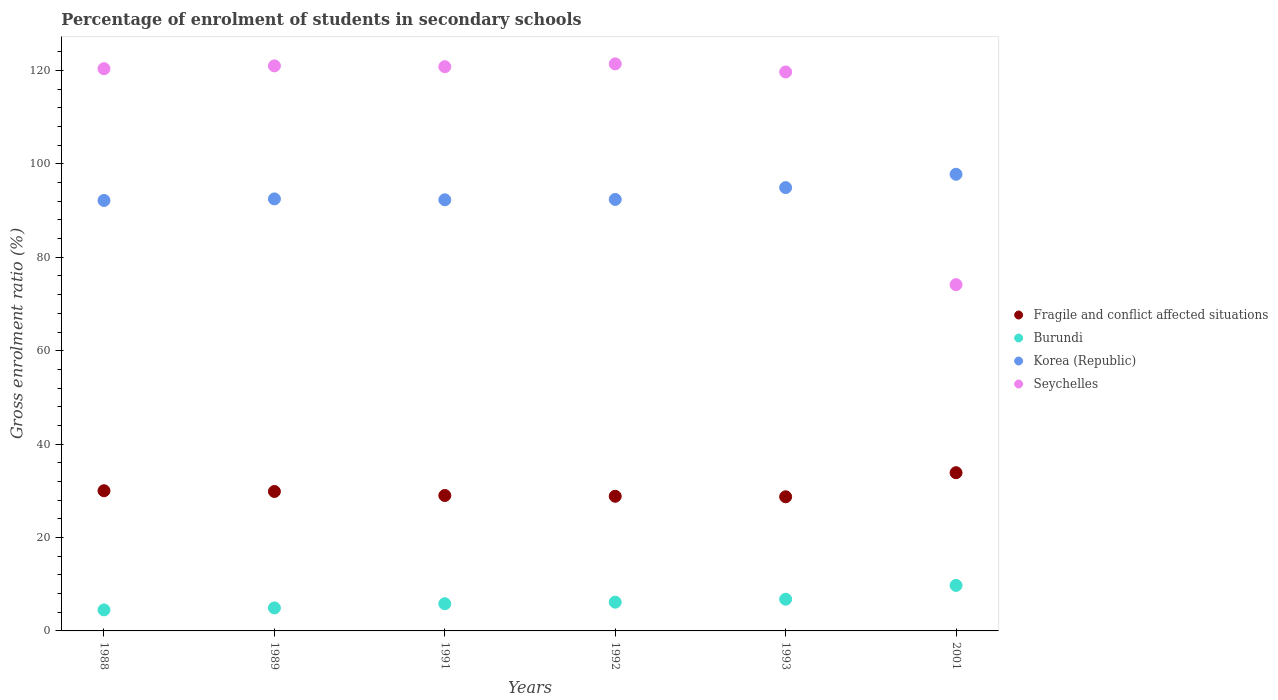How many different coloured dotlines are there?
Ensure brevity in your answer.  4. What is the percentage of students enrolled in secondary schools in Korea (Republic) in 2001?
Provide a short and direct response. 97.77. Across all years, what is the maximum percentage of students enrolled in secondary schools in Burundi?
Your answer should be very brief. 9.75. Across all years, what is the minimum percentage of students enrolled in secondary schools in Seychelles?
Provide a short and direct response. 74.14. In which year was the percentage of students enrolled in secondary schools in Fragile and conflict affected situations maximum?
Make the answer very short. 2001. In which year was the percentage of students enrolled in secondary schools in Fragile and conflict affected situations minimum?
Make the answer very short. 1993. What is the total percentage of students enrolled in secondary schools in Seychelles in the graph?
Ensure brevity in your answer.  677.37. What is the difference between the percentage of students enrolled in secondary schools in Seychelles in 1989 and that in 2001?
Offer a terse response. 46.85. What is the difference between the percentage of students enrolled in secondary schools in Burundi in 1991 and the percentage of students enrolled in secondary schools in Korea (Republic) in 1992?
Provide a short and direct response. -86.56. What is the average percentage of students enrolled in secondary schools in Seychelles per year?
Your answer should be very brief. 112.9. In the year 1988, what is the difference between the percentage of students enrolled in secondary schools in Seychelles and percentage of students enrolled in secondary schools in Fragile and conflict affected situations?
Keep it short and to the point. 90.36. In how many years, is the percentage of students enrolled in secondary schools in Seychelles greater than 120 %?
Offer a very short reply. 4. What is the ratio of the percentage of students enrolled in secondary schools in Korea (Republic) in 1989 to that in 2001?
Make the answer very short. 0.95. Is the difference between the percentage of students enrolled in secondary schools in Seychelles in 1988 and 2001 greater than the difference between the percentage of students enrolled in secondary schools in Fragile and conflict affected situations in 1988 and 2001?
Make the answer very short. Yes. What is the difference between the highest and the second highest percentage of students enrolled in secondary schools in Seychelles?
Provide a succinct answer. 0.43. What is the difference between the highest and the lowest percentage of students enrolled in secondary schools in Seychelles?
Give a very brief answer. 47.27. Is the sum of the percentage of students enrolled in secondary schools in Fragile and conflict affected situations in 1989 and 1992 greater than the maximum percentage of students enrolled in secondary schools in Burundi across all years?
Make the answer very short. Yes. Does the percentage of students enrolled in secondary schools in Burundi monotonically increase over the years?
Give a very brief answer. Yes. Is the percentage of students enrolled in secondary schools in Burundi strictly greater than the percentage of students enrolled in secondary schools in Korea (Republic) over the years?
Offer a very short reply. No. How many years are there in the graph?
Your answer should be very brief. 6. Are the values on the major ticks of Y-axis written in scientific E-notation?
Your answer should be compact. No. Does the graph contain any zero values?
Your answer should be compact. No. Does the graph contain grids?
Provide a succinct answer. No. How many legend labels are there?
Offer a terse response. 4. What is the title of the graph?
Ensure brevity in your answer.  Percentage of enrolment of students in secondary schools. What is the label or title of the X-axis?
Provide a short and direct response. Years. What is the label or title of the Y-axis?
Ensure brevity in your answer.  Gross enrolment ratio (%). What is the Gross enrolment ratio (%) of Fragile and conflict affected situations in 1988?
Provide a succinct answer. 30.01. What is the Gross enrolment ratio (%) in Burundi in 1988?
Keep it short and to the point. 4.5. What is the Gross enrolment ratio (%) in Korea (Republic) in 1988?
Your response must be concise. 92.16. What is the Gross enrolment ratio (%) of Seychelles in 1988?
Provide a short and direct response. 120.37. What is the Gross enrolment ratio (%) in Fragile and conflict affected situations in 1989?
Make the answer very short. 29.86. What is the Gross enrolment ratio (%) of Burundi in 1989?
Ensure brevity in your answer.  4.93. What is the Gross enrolment ratio (%) of Korea (Republic) in 1989?
Offer a terse response. 92.5. What is the Gross enrolment ratio (%) in Seychelles in 1989?
Your answer should be compact. 120.98. What is the Gross enrolment ratio (%) of Fragile and conflict affected situations in 1991?
Ensure brevity in your answer.  29. What is the Gross enrolment ratio (%) of Burundi in 1991?
Provide a short and direct response. 5.82. What is the Gross enrolment ratio (%) in Korea (Republic) in 1991?
Give a very brief answer. 92.31. What is the Gross enrolment ratio (%) in Seychelles in 1991?
Provide a short and direct response. 120.8. What is the Gross enrolment ratio (%) of Fragile and conflict affected situations in 1992?
Keep it short and to the point. 28.83. What is the Gross enrolment ratio (%) in Burundi in 1992?
Offer a very short reply. 6.16. What is the Gross enrolment ratio (%) of Korea (Republic) in 1992?
Give a very brief answer. 92.38. What is the Gross enrolment ratio (%) of Seychelles in 1992?
Your answer should be compact. 121.41. What is the Gross enrolment ratio (%) in Fragile and conflict affected situations in 1993?
Your answer should be compact. 28.72. What is the Gross enrolment ratio (%) of Burundi in 1993?
Make the answer very short. 6.79. What is the Gross enrolment ratio (%) of Korea (Republic) in 1993?
Make the answer very short. 94.91. What is the Gross enrolment ratio (%) in Seychelles in 1993?
Give a very brief answer. 119.68. What is the Gross enrolment ratio (%) of Fragile and conflict affected situations in 2001?
Your answer should be compact. 33.87. What is the Gross enrolment ratio (%) of Burundi in 2001?
Keep it short and to the point. 9.75. What is the Gross enrolment ratio (%) in Korea (Republic) in 2001?
Your response must be concise. 97.77. What is the Gross enrolment ratio (%) of Seychelles in 2001?
Your answer should be compact. 74.14. Across all years, what is the maximum Gross enrolment ratio (%) in Fragile and conflict affected situations?
Ensure brevity in your answer.  33.87. Across all years, what is the maximum Gross enrolment ratio (%) of Burundi?
Ensure brevity in your answer.  9.75. Across all years, what is the maximum Gross enrolment ratio (%) in Korea (Republic)?
Provide a short and direct response. 97.77. Across all years, what is the maximum Gross enrolment ratio (%) in Seychelles?
Your answer should be compact. 121.41. Across all years, what is the minimum Gross enrolment ratio (%) of Fragile and conflict affected situations?
Ensure brevity in your answer.  28.72. Across all years, what is the minimum Gross enrolment ratio (%) in Burundi?
Your answer should be very brief. 4.5. Across all years, what is the minimum Gross enrolment ratio (%) in Korea (Republic)?
Your answer should be very brief. 92.16. Across all years, what is the minimum Gross enrolment ratio (%) of Seychelles?
Provide a short and direct response. 74.14. What is the total Gross enrolment ratio (%) of Fragile and conflict affected situations in the graph?
Your answer should be compact. 180.29. What is the total Gross enrolment ratio (%) in Burundi in the graph?
Your answer should be compact. 37.94. What is the total Gross enrolment ratio (%) of Korea (Republic) in the graph?
Your answer should be compact. 562.04. What is the total Gross enrolment ratio (%) in Seychelles in the graph?
Keep it short and to the point. 677.37. What is the difference between the Gross enrolment ratio (%) of Fragile and conflict affected situations in 1988 and that in 1989?
Give a very brief answer. 0.16. What is the difference between the Gross enrolment ratio (%) of Burundi in 1988 and that in 1989?
Provide a short and direct response. -0.42. What is the difference between the Gross enrolment ratio (%) in Korea (Republic) in 1988 and that in 1989?
Offer a very short reply. -0.33. What is the difference between the Gross enrolment ratio (%) of Seychelles in 1988 and that in 1989?
Ensure brevity in your answer.  -0.61. What is the difference between the Gross enrolment ratio (%) of Fragile and conflict affected situations in 1988 and that in 1991?
Keep it short and to the point. 1.02. What is the difference between the Gross enrolment ratio (%) of Burundi in 1988 and that in 1991?
Offer a terse response. -1.32. What is the difference between the Gross enrolment ratio (%) in Korea (Republic) in 1988 and that in 1991?
Provide a short and direct response. -0.14. What is the difference between the Gross enrolment ratio (%) of Seychelles in 1988 and that in 1991?
Provide a succinct answer. -0.42. What is the difference between the Gross enrolment ratio (%) in Fragile and conflict affected situations in 1988 and that in 1992?
Make the answer very short. 1.18. What is the difference between the Gross enrolment ratio (%) in Burundi in 1988 and that in 1992?
Make the answer very short. -1.65. What is the difference between the Gross enrolment ratio (%) of Korea (Republic) in 1988 and that in 1992?
Make the answer very short. -0.22. What is the difference between the Gross enrolment ratio (%) in Seychelles in 1988 and that in 1992?
Make the answer very short. -1.03. What is the difference between the Gross enrolment ratio (%) in Fragile and conflict affected situations in 1988 and that in 1993?
Offer a very short reply. 1.29. What is the difference between the Gross enrolment ratio (%) of Burundi in 1988 and that in 1993?
Your answer should be very brief. -2.29. What is the difference between the Gross enrolment ratio (%) in Korea (Republic) in 1988 and that in 1993?
Keep it short and to the point. -2.75. What is the difference between the Gross enrolment ratio (%) in Seychelles in 1988 and that in 1993?
Ensure brevity in your answer.  0.7. What is the difference between the Gross enrolment ratio (%) of Fragile and conflict affected situations in 1988 and that in 2001?
Provide a short and direct response. -3.86. What is the difference between the Gross enrolment ratio (%) in Burundi in 1988 and that in 2001?
Give a very brief answer. -5.24. What is the difference between the Gross enrolment ratio (%) of Korea (Republic) in 1988 and that in 2001?
Offer a terse response. -5.61. What is the difference between the Gross enrolment ratio (%) of Seychelles in 1988 and that in 2001?
Keep it short and to the point. 46.24. What is the difference between the Gross enrolment ratio (%) of Fragile and conflict affected situations in 1989 and that in 1991?
Provide a short and direct response. 0.86. What is the difference between the Gross enrolment ratio (%) in Burundi in 1989 and that in 1991?
Provide a succinct answer. -0.9. What is the difference between the Gross enrolment ratio (%) of Korea (Republic) in 1989 and that in 1991?
Your answer should be very brief. 0.19. What is the difference between the Gross enrolment ratio (%) of Seychelles in 1989 and that in 1991?
Keep it short and to the point. 0.18. What is the difference between the Gross enrolment ratio (%) in Fragile and conflict affected situations in 1989 and that in 1992?
Offer a very short reply. 1.03. What is the difference between the Gross enrolment ratio (%) in Burundi in 1989 and that in 1992?
Your answer should be very brief. -1.23. What is the difference between the Gross enrolment ratio (%) in Korea (Republic) in 1989 and that in 1992?
Make the answer very short. 0.11. What is the difference between the Gross enrolment ratio (%) in Seychelles in 1989 and that in 1992?
Offer a terse response. -0.43. What is the difference between the Gross enrolment ratio (%) of Fragile and conflict affected situations in 1989 and that in 1993?
Keep it short and to the point. 1.14. What is the difference between the Gross enrolment ratio (%) in Burundi in 1989 and that in 1993?
Provide a short and direct response. -1.86. What is the difference between the Gross enrolment ratio (%) in Korea (Republic) in 1989 and that in 1993?
Give a very brief answer. -2.42. What is the difference between the Gross enrolment ratio (%) in Seychelles in 1989 and that in 1993?
Offer a very short reply. 1.3. What is the difference between the Gross enrolment ratio (%) of Fragile and conflict affected situations in 1989 and that in 2001?
Provide a short and direct response. -4.02. What is the difference between the Gross enrolment ratio (%) in Burundi in 1989 and that in 2001?
Make the answer very short. -4.82. What is the difference between the Gross enrolment ratio (%) in Korea (Republic) in 1989 and that in 2001?
Your response must be concise. -5.28. What is the difference between the Gross enrolment ratio (%) in Seychelles in 1989 and that in 2001?
Your answer should be compact. 46.85. What is the difference between the Gross enrolment ratio (%) in Fragile and conflict affected situations in 1991 and that in 1992?
Provide a short and direct response. 0.17. What is the difference between the Gross enrolment ratio (%) in Burundi in 1991 and that in 1992?
Give a very brief answer. -0.33. What is the difference between the Gross enrolment ratio (%) in Korea (Republic) in 1991 and that in 1992?
Ensure brevity in your answer.  -0.08. What is the difference between the Gross enrolment ratio (%) of Seychelles in 1991 and that in 1992?
Ensure brevity in your answer.  -0.61. What is the difference between the Gross enrolment ratio (%) of Fragile and conflict affected situations in 1991 and that in 1993?
Ensure brevity in your answer.  0.28. What is the difference between the Gross enrolment ratio (%) of Burundi in 1991 and that in 1993?
Your response must be concise. -0.97. What is the difference between the Gross enrolment ratio (%) in Korea (Republic) in 1991 and that in 1993?
Provide a succinct answer. -2.61. What is the difference between the Gross enrolment ratio (%) of Seychelles in 1991 and that in 1993?
Your answer should be very brief. 1.12. What is the difference between the Gross enrolment ratio (%) of Fragile and conflict affected situations in 1991 and that in 2001?
Offer a terse response. -4.88. What is the difference between the Gross enrolment ratio (%) of Burundi in 1991 and that in 2001?
Your answer should be very brief. -3.92. What is the difference between the Gross enrolment ratio (%) of Korea (Republic) in 1991 and that in 2001?
Ensure brevity in your answer.  -5.46. What is the difference between the Gross enrolment ratio (%) in Seychelles in 1991 and that in 2001?
Provide a succinct answer. 46.66. What is the difference between the Gross enrolment ratio (%) of Fragile and conflict affected situations in 1992 and that in 1993?
Keep it short and to the point. 0.11. What is the difference between the Gross enrolment ratio (%) in Burundi in 1992 and that in 1993?
Keep it short and to the point. -0.63. What is the difference between the Gross enrolment ratio (%) in Korea (Republic) in 1992 and that in 1993?
Provide a short and direct response. -2.53. What is the difference between the Gross enrolment ratio (%) in Seychelles in 1992 and that in 1993?
Make the answer very short. 1.73. What is the difference between the Gross enrolment ratio (%) of Fragile and conflict affected situations in 1992 and that in 2001?
Your answer should be very brief. -5.04. What is the difference between the Gross enrolment ratio (%) of Burundi in 1992 and that in 2001?
Give a very brief answer. -3.59. What is the difference between the Gross enrolment ratio (%) in Korea (Republic) in 1992 and that in 2001?
Your answer should be compact. -5.39. What is the difference between the Gross enrolment ratio (%) of Seychelles in 1992 and that in 2001?
Your answer should be very brief. 47.27. What is the difference between the Gross enrolment ratio (%) of Fragile and conflict affected situations in 1993 and that in 2001?
Keep it short and to the point. -5.15. What is the difference between the Gross enrolment ratio (%) in Burundi in 1993 and that in 2001?
Your answer should be compact. -2.96. What is the difference between the Gross enrolment ratio (%) in Korea (Republic) in 1993 and that in 2001?
Your response must be concise. -2.86. What is the difference between the Gross enrolment ratio (%) of Seychelles in 1993 and that in 2001?
Offer a very short reply. 45.54. What is the difference between the Gross enrolment ratio (%) in Fragile and conflict affected situations in 1988 and the Gross enrolment ratio (%) in Burundi in 1989?
Your answer should be very brief. 25.09. What is the difference between the Gross enrolment ratio (%) in Fragile and conflict affected situations in 1988 and the Gross enrolment ratio (%) in Korea (Republic) in 1989?
Provide a short and direct response. -62.48. What is the difference between the Gross enrolment ratio (%) in Fragile and conflict affected situations in 1988 and the Gross enrolment ratio (%) in Seychelles in 1989?
Offer a terse response. -90.97. What is the difference between the Gross enrolment ratio (%) in Burundi in 1988 and the Gross enrolment ratio (%) in Korea (Republic) in 1989?
Make the answer very short. -87.99. What is the difference between the Gross enrolment ratio (%) in Burundi in 1988 and the Gross enrolment ratio (%) in Seychelles in 1989?
Make the answer very short. -116.48. What is the difference between the Gross enrolment ratio (%) of Korea (Republic) in 1988 and the Gross enrolment ratio (%) of Seychelles in 1989?
Make the answer very short. -28.82. What is the difference between the Gross enrolment ratio (%) of Fragile and conflict affected situations in 1988 and the Gross enrolment ratio (%) of Burundi in 1991?
Your answer should be compact. 24.19. What is the difference between the Gross enrolment ratio (%) in Fragile and conflict affected situations in 1988 and the Gross enrolment ratio (%) in Korea (Republic) in 1991?
Ensure brevity in your answer.  -62.3. What is the difference between the Gross enrolment ratio (%) in Fragile and conflict affected situations in 1988 and the Gross enrolment ratio (%) in Seychelles in 1991?
Keep it short and to the point. -90.79. What is the difference between the Gross enrolment ratio (%) of Burundi in 1988 and the Gross enrolment ratio (%) of Korea (Republic) in 1991?
Your response must be concise. -87.81. What is the difference between the Gross enrolment ratio (%) of Burundi in 1988 and the Gross enrolment ratio (%) of Seychelles in 1991?
Your answer should be very brief. -116.3. What is the difference between the Gross enrolment ratio (%) in Korea (Republic) in 1988 and the Gross enrolment ratio (%) in Seychelles in 1991?
Offer a terse response. -28.63. What is the difference between the Gross enrolment ratio (%) in Fragile and conflict affected situations in 1988 and the Gross enrolment ratio (%) in Burundi in 1992?
Your answer should be compact. 23.86. What is the difference between the Gross enrolment ratio (%) of Fragile and conflict affected situations in 1988 and the Gross enrolment ratio (%) of Korea (Republic) in 1992?
Keep it short and to the point. -62.37. What is the difference between the Gross enrolment ratio (%) of Fragile and conflict affected situations in 1988 and the Gross enrolment ratio (%) of Seychelles in 1992?
Provide a short and direct response. -91.39. What is the difference between the Gross enrolment ratio (%) in Burundi in 1988 and the Gross enrolment ratio (%) in Korea (Republic) in 1992?
Your answer should be compact. -87.88. What is the difference between the Gross enrolment ratio (%) in Burundi in 1988 and the Gross enrolment ratio (%) in Seychelles in 1992?
Keep it short and to the point. -116.9. What is the difference between the Gross enrolment ratio (%) in Korea (Republic) in 1988 and the Gross enrolment ratio (%) in Seychelles in 1992?
Offer a very short reply. -29.24. What is the difference between the Gross enrolment ratio (%) of Fragile and conflict affected situations in 1988 and the Gross enrolment ratio (%) of Burundi in 1993?
Give a very brief answer. 23.22. What is the difference between the Gross enrolment ratio (%) of Fragile and conflict affected situations in 1988 and the Gross enrolment ratio (%) of Korea (Republic) in 1993?
Keep it short and to the point. -64.9. What is the difference between the Gross enrolment ratio (%) in Fragile and conflict affected situations in 1988 and the Gross enrolment ratio (%) in Seychelles in 1993?
Make the answer very short. -89.66. What is the difference between the Gross enrolment ratio (%) in Burundi in 1988 and the Gross enrolment ratio (%) in Korea (Republic) in 1993?
Provide a short and direct response. -90.41. What is the difference between the Gross enrolment ratio (%) in Burundi in 1988 and the Gross enrolment ratio (%) in Seychelles in 1993?
Your answer should be very brief. -115.17. What is the difference between the Gross enrolment ratio (%) in Korea (Republic) in 1988 and the Gross enrolment ratio (%) in Seychelles in 1993?
Give a very brief answer. -27.51. What is the difference between the Gross enrolment ratio (%) in Fragile and conflict affected situations in 1988 and the Gross enrolment ratio (%) in Burundi in 2001?
Give a very brief answer. 20.27. What is the difference between the Gross enrolment ratio (%) in Fragile and conflict affected situations in 1988 and the Gross enrolment ratio (%) in Korea (Republic) in 2001?
Provide a succinct answer. -67.76. What is the difference between the Gross enrolment ratio (%) of Fragile and conflict affected situations in 1988 and the Gross enrolment ratio (%) of Seychelles in 2001?
Provide a succinct answer. -44.12. What is the difference between the Gross enrolment ratio (%) in Burundi in 1988 and the Gross enrolment ratio (%) in Korea (Republic) in 2001?
Your response must be concise. -93.27. What is the difference between the Gross enrolment ratio (%) in Burundi in 1988 and the Gross enrolment ratio (%) in Seychelles in 2001?
Provide a succinct answer. -69.63. What is the difference between the Gross enrolment ratio (%) of Korea (Republic) in 1988 and the Gross enrolment ratio (%) of Seychelles in 2001?
Keep it short and to the point. 18.03. What is the difference between the Gross enrolment ratio (%) of Fragile and conflict affected situations in 1989 and the Gross enrolment ratio (%) of Burundi in 1991?
Your response must be concise. 24.04. What is the difference between the Gross enrolment ratio (%) in Fragile and conflict affected situations in 1989 and the Gross enrolment ratio (%) in Korea (Republic) in 1991?
Provide a short and direct response. -62.45. What is the difference between the Gross enrolment ratio (%) in Fragile and conflict affected situations in 1989 and the Gross enrolment ratio (%) in Seychelles in 1991?
Your answer should be very brief. -90.94. What is the difference between the Gross enrolment ratio (%) of Burundi in 1989 and the Gross enrolment ratio (%) of Korea (Republic) in 1991?
Your answer should be very brief. -87.38. What is the difference between the Gross enrolment ratio (%) in Burundi in 1989 and the Gross enrolment ratio (%) in Seychelles in 1991?
Keep it short and to the point. -115.87. What is the difference between the Gross enrolment ratio (%) of Korea (Republic) in 1989 and the Gross enrolment ratio (%) of Seychelles in 1991?
Your answer should be compact. -28.3. What is the difference between the Gross enrolment ratio (%) of Fragile and conflict affected situations in 1989 and the Gross enrolment ratio (%) of Burundi in 1992?
Ensure brevity in your answer.  23.7. What is the difference between the Gross enrolment ratio (%) of Fragile and conflict affected situations in 1989 and the Gross enrolment ratio (%) of Korea (Republic) in 1992?
Keep it short and to the point. -62.53. What is the difference between the Gross enrolment ratio (%) in Fragile and conflict affected situations in 1989 and the Gross enrolment ratio (%) in Seychelles in 1992?
Your answer should be compact. -91.55. What is the difference between the Gross enrolment ratio (%) in Burundi in 1989 and the Gross enrolment ratio (%) in Korea (Republic) in 1992?
Your answer should be very brief. -87.46. What is the difference between the Gross enrolment ratio (%) of Burundi in 1989 and the Gross enrolment ratio (%) of Seychelles in 1992?
Offer a very short reply. -116.48. What is the difference between the Gross enrolment ratio (%) in Korea (Republic) in 1989 and the Gross enrolment ratio (%) in Seychelles in 1992?
Offer a terse response. -28.91. What is the difference between the Gross enrolment ratio (%) in Fragile and conflict affected situations in 1989 and the Gross enrolment ratio (%) in Burundi in 1993?
Offer a very short reply. 23.07. What is the difference between the Gross enrolment ratio (%) of Fragile and conflict affected situations in 1989 and the Gross enrolment ratio (%) of Korea (Republic) in 1993?
Make the answer very short. -65.06. What is the difference between the Gross enrolment ratio (%) of Fragile and conflict affected situations in 1989 and the Gross enrolment ratio (%) of Seychelles in 1993?
Give a very brief answer. -89.82. What is the difference between the Gross enrolment ratio (%) of Burundi in 1989 and the Gross enrolment ratio (%) of Korea (Republic) in 1993?
Give a very brief answer. -89.99. What is the difference between the Gross enrolment ratio (%) in Burundi in 1989 and the Gross enrolment ratio (%) in Seychelles in 1993?
Ensure brevity in your answer.  -114.75. What is the difference between the Gross enrolment ratio (%) of Korea (Republic) in 1989 and the Gross enrolment ratio (%) of Seychelles in 1993?
Keep it short and to the point. -27.18. What is the difference between the Gross enrolment ratio (%) in Fragile and conflict affected situations in 1989 and the Gross enrolment ratio (%) in Burundi in 2001?
Your response must be concise. 20.11. What is the difference between the Gross enrolment ratio (%) in Fragile and conflict affected situations in 1989 and the Gross enrolment ratio (%) in Korea (Republic) in 2001?
Provide a short and direct response. -67.92. What is the difference between the Gross enrolment ratio (%) in Fragile and conflict affected situations in 1989 and the Gross enrolment ratio (%) in Seychelles in 2001?
Ensure brevity in your answer.  -44.28. What is the difference between the Gross enrolment ratio (%) of Burundi in 1989 and the Gross enrolment ratio (%) of Korea (Republic) in 2001?
Make the answer very short. -92.85. What is the difference between the Gross enrolment ratio (%) of Burundi in 1989 and the Gross enrolment ratio (%) of Seychelles in 2001?
Give a very brief answer. -69.21. What is the difference between the Gross enrolment ratio (%) in Korea (Republic) in 1989 and the Gross enrolment ratio (%) in Seychelles in 2001?
Offer a very short reply. 18.36. What is the difference between the Gross enrolment ratio (%) in Fragile and conflict affected situations in 1991 and the Gross enrolment ratio (%) in Burundi in 1992?
Keep it short and to the point. 22.84. What is the difference between the Gross enrolment ratio (%) in Fragile and conflict affected situations in 1991 and the Gross enrolment ratio (%) in Korea (Republic) in 1992?
Offer a very short reply. -63.39. What is the difference between the Gross enrolment ratio (%) in Fragile and conflict affected situations in 1991 and the Gross enrolment ratio (%) in Seychelles in 1992?
Provide a succinct answer. -92.41. What is the difference between the Gross enrolment ratio (%) in Burundi in 1991 and the Gross enrolment ratio (%) in Korea (Republic) in 1992?
Provide a succinct answer. -86.56. What is the difference between the Gross enrolment ratio (%) of Burundi in 1991 and the Gross enrolment ratio (%) of Seychelles in 1992?
Give a very brief answer. -115.58. What is the difference between the Gross enrolment ratio (%) in Korea (Republic) in 1991 and the Gross enrolment ratio (%) in Seychelles in 1992?
Ensure brevity in your answer.  -29.1. What is the difference between the Gross enrolment ratio (%) in Fragile and conflict affected situations in 1991 and the Gross enrolment ratio (%) in Burundi in 1993?
Offer a very short reply. 22.21. What is the difference between the Gross enrolment ratio (%) in Fragile and conflict affected situations in 1991 and the Gross enrolment ratio (%) in Korea (Republic) in 1993?
Your answer should be compact. -65.92. What is the difference between the Gross enrolment ratio (%) of Fragile and conflict affected situations in 1991 and the Gross enrolment ratio (%) of Seychelles in 1993?
Offer a terse response. -90.68. What is the difference between the Gross enrolment ratio (%) of Burundi in 1991 and the Gross enrolment ratio (%) of Korea (Republic) in 1993?
Give a very brief answer. -89.09. What is the difference between the Gross enrolment ratio (%) of Burundi in 1991 and the Gross enrolment ratio (%) of Seychelles in 1993?
Offer a terse response. -113.85. What is the difference between the Gross enrolment ratio (%) of Korea (Republic) in 1991 and the Gross enrolment ratio (%) of Seychelles in 1993?
Offer a very short reply. -27.37. What is the difference between the Gross enrolment ratio (%) in Fragile and conflict affected situations in 1991 and the Gross enrolment ratio (%) in Burundi in 2001?
Offer a very short reply. 19.25. What is the difference between the Gross enrolment ratio (%) of Fragile and conflict affected situations in 1991 and the Gross enrolment ratio (%) of Korea (Republic) in 2001?
Offer a very short reply. -68.78. What is the difference between the Gross enrolment ratio (%) in Fragile and conflict affected situations in 1991 and the Gross enrolment ratio (%) in Seychelles in 2001?
Your response must be concise. -45.14. What is the difference between the Gross enrolment ratio (%) of Burundi in 1991 and the Gross enrolment ratio (%) of Korea (Republic) in 2001?
Your answer should be very brief. -91.95. What is the difference between the Gross enrolment ratio (%) of Burundi in 1991 and the Gross enrolment ratio (%) of Seychelles in 2001?
Your response must be concise. -68.31. What is the difference between the Gross enrolment ratio (%) of Korea (Republic) in 1991 and the Gross enrolment ratio (%) of Seychelles in 2001?
Offer a very short reply. 18.17. What is the difference between the Gross enrolment ratio (%) in Fragile and conflict affected situations in 1992 and the Gross enrolment ratio (%) in Burundi in 1993?
Provide a succinct answer. 22.04. What is the difference between the Gross enrolment ratio (%) of Fragile and conflict affected situations in 1992 and the Gross enrolment ratio (%) of Korea (Republic) in 1993?
Provide a succinct answer. -66.09. What is the difference between the Gross enrolment ratio (%) in Fragile and conflict affected situations in 1992 and the Gross enrolment ratio (%) in Seychelles in 1993?
Keep it short and to the point. -90.85. What is the difference between the Gross enrolment ratio (%) in Burundi in 1992 and the Gross enrolment ratio (%) in Korea (Republic) in 1993?
Your answer should be very brief. -88.76. What is the difference between the Gross enrolment ratio (%) in Burundi in 1992 and the Gross enrolment ratio (%) in Seychelles in 1993?
Ensure brevity in your answer.  -113.52. What is the difference between the Gross enrolment ratio (%) of Korea (Republic) in 1992 and the Gross enrolment ratio (%) of Seychelles in 1993?
Your response must be concise. -27.29. What is the difference between the Gross enrolment ratio (%) of Fragile and conflict affected situations in 1992 and the Gross enrolment ratio (%) of Burundi in 2001?
Provide a short and direct response. 19.08. What is the difference between the Gross enrolment ratio (%) in Fragile and conflict affected situations in 1992 and the Gross enrolment ratio (%) in Korea (Republic) in 2001?
Your response must be concise. -68.94. What is the difference between the Gross enrolment ratio (%) of Fragile and conflict affected situations in 1992 and the Gross enrolment ratio (%) of Seychelles in 2001?
Make the answer very short. -45.31. What is the difference between the Gross enrolment ratio (%) of Burundi in 1992 and the Gross enrolment ratio (%) of Korea (Republic) in 2001?
Your response must be concise. -91.62. What is the difference between the Gross enrolment ratio (%) in Burundi in 1992 and the Gross enrolment ratio (%) in Seychelles in 2001?
Keep it short and to the point. -67.98. What is the difference between the Gross enrolment ratio (%) of Korea (Republic) in 1992 and the Gross enrolment ratio (%) of Seychelles in 2001?
Ensure brevity in your answer.  18.25. What is the difference between the Gross enrolment ratio (%) of Fragile and conflict affected situations in 1993 and the Gross enrolment ratio (%) of Burundi in 2001?
Make the answer very short. 18.97. What is the difference between the Gross enrolment ratio (%) of Fragile and conflict affected situations in 1993 and the Gross enrolment ratio (%) of Korea (Republic) in 2001?
Ensure brevity in your answer.  -69.05. What is the difference between the Gross enrolment ratio (%) in Fragile and conflict affected situations in 1993 and the Gross enrolment ratio (%) in Seychelles in 2001?
Your answer should be compact. -45.42. What is the difference between the Gross enrolment ratio (%) of Burundi in 1993 and the Gross enrolment ratio (%) of Korea (Republic) in 2001?
Provide a succinct answer. -90.98. What is the difference between the Gross enrolment ratio (%) of Burundi in 1993 and the Gross enrolment ratio (%) of Seychelles in 2001?
Your answer should be compact. -67.35. What is the difference between the Gross enrolment ratio (%) of Korea (Republic) in 1993 and the Gross enrolment ratio (%) of Seychelles in 2001?
Ensure brevity in your answer.  20.78. What is the average Gross enrolment ratio (%) in Fragile and conflict affected situations per year?
Your answer should be very brief. 30.05. What is the average Gross enrolment ratio (%) of Burundi per year?
Offer a terse response. 6.32. What is the average Gross enrolment ratio (%) of Korea (Republic) per year?
Your answer should be very brief. 93.67. What is the average Gross enrolment ratio (%) of Seychelles per year?
Offer a terse response. 112.9. In the year 1988, what is the difference between the Gross enrolment ratio (%) of Fragile and conflict affected situations and Gross enrolment ratio (%) of Burundi?
Provide a succinct answer. 25.51. In the year 1988, what is the difference between the Gross enrolment ratio (%) in Fragile and conflict affected situations and Gross enrolment ratio (%) in Korea (Republic)?
Your answer should be compact. -62.15. In the year 1988, what is the difference between the Gross enrolment ratio (%) of Fragile and conflict affected situations and Gross enrolment ratio (%) of Seychelles?
Your answer should be compact. -90.36. In the year 1988, what is the difference between the Gross enrolment ratio (%) in Burundi and Gross enrolment ratio (%) in Korea (Republic)?
Your answer should be very brief. -87.66. In the year 1988, what is the difference between the Gross enrolment ratio (%) of Burundi and Gross enrolment ratio (%) of Seychelles?
Ensure brevity in your answer.  -115.87. In the year 1988, what is the difference between the Gross enrolment ratio (%) in Korea (Republic) and Gross enrolment ratio (%) in Seychelles?
Offer a very short reply. -28.21. In the year 1989, what is the difference between the Gross enrolment ratio (%) of Fragile and conflict affected situations and Gross enrolment ratio (%) of Burundi?
Give a very brief answer. 24.93. In the year 1989, what is the difference between the Gross enrolment ratio (%) of Fragile and conflict affected situations and Gross enrolment ratio (%) of Korea (Republic)?
Provide a short and direct response. -62.64. In the year 1989, what is the difference between the Gross enrolment ratio (%) in Fragile and conflict affected situations and Gross enrolment ratio (%) in Seychelles?
Your answer should be very brief. -91.12. In the year 1989, what is the difference between the Gross enrolment ratio (%) of Burundi and Gross enrolment ratio (%) of Korea (Republic)?
Give a very brief answer. -87.57. In the year 1989, what is the difference between the Gross enrolment ratio (%) of Burundi and Gross enrolment ratio (%) of Seychelles?
Offer a terse response. -116.06. In the year 1989, what is the difference between the Gross enrolment ratio (%) in Korea (Republic) and Gross enrolment ratio (%) in Seychelles?
Make the answer very short. -28.49. In the year 1991, what is the difference between the Gross enrolment ratio (%) in Fragile and conflict affected situations and Gross enrolment ratio (%) in Burundi?
Offer a terse response. 23.17. In the year 1991, what is the difference between the Gross enrolment ratio (%) of Fragile and conflict affected situations and Gross enrolment ratio (%) of Korea (Republic)?
Provide a succinct answer. -63.31. In the year 1991, what is the difference between the Gross enrolment ratio (%) in Fragile and conflict affected situations and Gross enrolment ratio (%) in Seychelles?
Your response must be concise. -91.8. In the year 1991, what is the difference between the Gross enrolment ratio (%) in Burundi and Gross enrolment ratio (%) in Korea (Republic)?
Your response must be concise. -86.49. In the year 1991, what is the difference between the Gross enrolment ratio (%) of Burundi and Gross enrolment ratio (%) of Seychelles?
Keep it short and to the point. -114.98. In the year 1991, what is the difference between the Gross enrolment ratio (%) of Korea (Republic) and Gross enrolment ratio (%) of Seychelles?
Offer a very short reply. -28.49. In the year 1992, what is the difference between the Gross enrolment ratio (%) of Fragile and conflict affected situations and Gross enrolment ratio (%) of Burundi?
Ensure brevity in your answer.  22.67. In the year 1992, what is the difference between the Gross enrolment ratio (%) in Fragile and conflict affected situations and Gross enrolment ratio (%) in Korea (Republic)?
Your response must be concise. -63.55. In the year 1992, what is the difference between the Gross enrolment ratio (%) in Fragile and conflict affected situations and Gross enrolment ratio (%) in Seychelles?
Provide a succinct answer. -92.58. In the year 1992, what is the difference between the Gross enrolment ratio (%) in Burundi and Gross enrolment ratio (%) in Korea (Republic)?
Offer a very short reply. -86.23. In the year 1992, what is the difference between the Gross enrolment ratio (%) in Burundi and Gross enrolment ratio (%) in Seychelles?
Provide a succinct answer. -115.25. In the year 1992, what is the difference between the Gross enrolment ratio (%) of Korea (Republic) and Gross enrolment ratio (%) of Seychelles?
Provide a succinct answer. -29.02. In the year 1993, what is the difference between the Gross enrolment ratio (%) in Fragile and conflict affected situations and Gross enrolment ratio (%) in Burundi?
Offer a terse response. 21.93. In the year 1993, what is the difference between the Gross enrolment ratio (%) of Fragile and conflict affected situations and Gross enrolment ratio (%) of Korea (Republic)?
Offer a very short reply. -66.2. In the year 1993, what is the difference between the Gross enrolment ratio (%) in Fragile and conflict affected situations and Gross enrolment ratio (%) in Seychelles?
Ensure brevity in your answer.  -90.96. In the year 1993, what is the difference between the Gross enrolment ratio (%) in Burundi and Gross enrolment ratio (%) in Korea (Republic)?
Give a very brief answer. -88.13. In the year 1993, what is the difference between the Gross enrolment ratio (%) in Burundi and Gross enrolment ratio (%) in Seychelles?
Offer a very short reply. -112.89. In the year 1993, what is the difference between the Gross enrolment ratio (%) of Korea (Republic) and Gross enrolment ratio (%) of Seychelles?
Give a very brief answer. -24.76. In the year 2001, what is the difference between the Gross enrolment ratio (%) of Fragile and conflict affected situations and Gross enrolment ratio (%) of Burundi?
Offer a terse response. 24.13. In the year 2001, what is the difference between the Gross enrolment ratio (%) in Fragile and conflict affected situations and Gross enrolment ratio (%) in Korea (Republic)?
Make the answer very short. -63.9. In the year 2001, what is the difference between the Gross enrolment ratio (%) of Fragile and conflict affected situations and Gross enrolment ratio (%) of Seychelles?
Offer a very short reply. -40.26. In the year 2001, what is the difference between the Gross enrolment ratio (%) in Burundi and Gross enrolment ratio (%) in Korea (Republic)?
Your response must be concise. -88.03. In the year 2001, what is the difference between the Gross enrolment ratio (%) in Burundi and Gross enrolment ratio (%) in Seychelles?
Offer a terse response. -64.39. In the year 2001, what is the difference between the Gross enrolment ratio (%) of Korea (Republic) and Gross enrolment ratio (%) of Seychelles?
Make the answer very short. 23.64. What is the ratio of the Gross enrolment ratio (%) in Fragile and conflict affected situations in 1988 to that in 1989?
Provide a short and direct response. 1.01. What is the ratio of the Gross enrolment ratio (%) in Burundi in 1988 to that in 1989?
Make the answer very short. 0.91. What is the ratio of the Gross enrolment ratio (%) of Korea (Republic) in 1988 to that in 1989?
Provide a succinct answer. 1. What is the ratio of the Gross enrolment ratio (%) of Fragile and conflict affected situations in 1988 to that in 1991?
Your response must be concise. 1.04. What is the ratio of the Gross enrolment ratio (%) in Burundi in 1988 to that in 1991?
Offer a very short reply. 0.77. What is the ratio of the Gross enrolment ratio (%) in Fragile and conflict affected situations in 1988 to that in 1992?
Offer a terse response. 1.04. What is the ratio of the Gross enrolment ratio (%) of Burundi in 1988 to that in 1992?
Your answer should be very brief. 0.73. What is the ratio of the Gross enrolment ratio (%) in Korea (Republic) in 1988 to that in 1992?
Your answer should be compact. 1. What is the ratio of the Gross enrolment ratio (%) in Fragile and conflict affected situations in 1988 to that in 1993?
Your answer should be very brief. 1.05. What is the ratio of the Gross enrolment ratio (%) in Burundi in 1988 to that in 1993?
Offer a terse response. 0.66. What is the ratio of the Gross enrolment ratio (%) in Seychelles in 1988 to that in 1993?
Your answer should be very brief. 1.01. What is the ratio of the Gross enrolment ratio (%) of Fragile and conflict affected situations in 1988 to that in 2001?
Ensure brevity in your answer.  0.89. What is the ratio of the Gross enrolment ratio (%) of Burundi in 1988 to that in 2001?
Give a very brief answer. 0.46. What is the ratio of the Gross enrolment ratio (%) in Korea (Republic) in 1988 to that in 2001?
Offer a very short reply. 0.94. What is the ratio of the Gross enrolment ratio (%) of Seychelles in 1988 to that in 2001?
Provide a short and direct response. 1.62. What is the ratio of the Gross enrolment ratio (%) in Fragile and conflict affected situations in 1989 to that in 1991?
Ensure brevity in your answer.  1.03. What is the ratio of the Gross enrolment ratio (%) of Burundi in 1989 to that in 1991?
Provide a succinct answer. 0.85. What is the ratio of the Gross enrolment ratio (%) in Korea (Republic) in 1989 to that in 1991?
Offer a terse response. 1. What is the ratio of the Gross enrolment ratio (%) in Seychelles in 1989 to that in 1991?
Provide a succinct answer. 1. What is the ratio of the Gross enrolment ratio (%) in Fragile and conflict affected situations in 1989 to that in 1992?
Ensure brevity in your answer.  1.04. What is the ratio of the Gross enrolment ratio (%) of Burundi in 1989 to that in 1992?
Your response must be concise. 0.8. What is the ratio of the Gross enrolment ratio (%) in Korea (Republic) in 1989 to that in 1992?
Your response must be concise. 1. What is the ratio of the Gross enrolment ratio (%) of Seychelles in 1989 to that in 1992?
Offer a terse response. 1. What is the ratio of the Gross enrolment ratio (%) in Fragile and conflict affected situations in 1989 to that in 1993?
Give a very brief answer. 1.04. What is the ratio of the Gross enrolment ratio (%) of Burundi in 1989 to that in 1993?
Offer a very short reply. 0.73. What is the ratio of the Gross enrolment ratio (%) of Korea (Republic) in 1989 to that in 1993?
Make the answer very short. 0.97. What is the ratio of the Gross enrolment ratio (%) of Seychelles in 1989 to that in 1993?
Your answer should be compact. 1.01. What is the ratio of the Gross enrolment ratio (%) in Fragile and conflict affected situations in 1989 to that in 2001?
Your response must be concise. 0.88. What is the ratio of the Gross enrolment ratio (%) in Burundi in 1989 to that in 2001?
Offer a terse response. 0.51. What is the ratio of the Gross enrolment ratio (%) of Korea (Republic) in 1989 to that in 2001?
Your answer should be compact. 0.95. What is the ratio of the Gross enrolment ratio (%) of Seychelles in 1989 to that in 2001?
Offer a terse response. 1.63. What is the ratio of the Gross enrolment ratio (%) of Burundi in 1991 to that in 1992?
Offer a terse response. 0.95. What is the ratio of the Gross enrolment ratio (%) in Fragile and conflict affected situations in 1991 to that in 1993?
Give a very brief answer. 1.01. What is the ratio of the Gross enrolment ratio (%) in Burundi in 1991 to that in 1993?
Provide a short and direct response. 0.86. What is the ratio of the Gross enrolment ratio (%) in Korea (Republic) in 1991 to that in 1993?
Offer a very short reply. 0.97. What is the ratio of the Gross enrolment ratio (%) of Seychelles in 1991 to that in 1993?
Offer a terse response. 1.01. What is the ratio of the Gross enrolment ratio (%) of Fragile and conflict affected situations in 1991 to that in 2001?
Offer a terse response. 0.86. What is the ratio of the Gross enrolment ratio (%) in Burundi in 1991 to that in 2001?
Ensure brevity in your answer.  0.6. What is the ratio of the Gross enrolment ratio (%) in Korea (Republic) in 1991 to that in 2001?
Give a very brief answer. 0.94. What is the ratio of the Gross enrolment ratio (%) of Seychelles in 1991 to that in 2001?
Your answer should be compact. 1.63. What is the ratio of the Gross enrolment ratio (%) in Fragile and conflict affected situations in 1992 to that in 1993?
Ensure brevity in your answer.  1. What is the ratio of the Gross enrolment ratio (%) in Burundi in 1992 to that in 1993?
Provide a succinct answer. 0.91. What is the ratio of the Gross enrolment ratio (%) in Korea (Republic) in 1992 to that in 1993?
Your response must be concise. 0.97. What is the ratio of the Gross enrolment ratio (%) of Seychelles in 1992 to that in 1993?
Offer a very short reply. 1.01. What is the ratio of the Gross enrolment ratio (%) in Fragile and conflict affected situations in 1992 to that in 2001?
Provide a succinct answer. 0.85. What is the ratio of the Gross enrolment ratio (%) in Burundi in 1992 to that in 2001?
Provide a succinct answer. 0.63. What is the ratio of the Gross enrolment ratio (%) in Korea (Republic) in 1992 to that in 2001?
Provide a succinct answer. 0.94. What is the ratio of the Gross enrolment ratio (%) of Seychelles in 1992 to that in 2001?
Offer a terse response. 1.64. What is the ratio of the Gross enrolment ratio (%) in Fragile and conflict affected situations in 1993 to that in 2001?
Provide a short and direct response. 0.85. What is the ratio of the Gross enrolment ratio (%) of Burundi in 1993 to that in 2001?
Offer a terse response. 0.7. What is the ratio of the Gross enrolment ratio (%) in Korea (Republic) in 1993 to that in 2001?
Ensure brevity in your answer.  0.97. What is the ratio of the Gross enrolment ratio (%) of Seychelles in 1993 to that in 2001?
Provide a short and direct response. 1.61. What is the difference between the highest and the second highest Gross enrolment ratio (%) in Fragile and conflict affected situations?
Your response must be concise. 3.86. What is the difference between the highest and the second highest Gross enrolment ratio (%) in Burundi?
Provide a succinct answer. 2.96. What is the difference between the highest and the second highest Gross enrolment ratio (%) of Korea (Republic)?
Provide a succinct answer. 2.86. What is the difference between the highest and the second highest Gross enrolment ratio (%) of Seychelles?
Offer a terse response. 0.43. What is the difference between the highest and the lowest Gross enrolment ratio (%) in Fragile and conflict affected situations?
Provide a short and direct response. 5.15. What is the difference between the highest and the lowest Gross enrolment ratio (%) of Burundi?
Make the answer very short. 5.24. What is the difference between the highest and the lowest Gross enrolment ratio (%) of Korea (Republic)?
Make the answer very short. 5.61. What is the difference between the highest and the lowest Gross enrolment ratio (%) in Seychelles?
Your answer should be very brief. 47.27. 